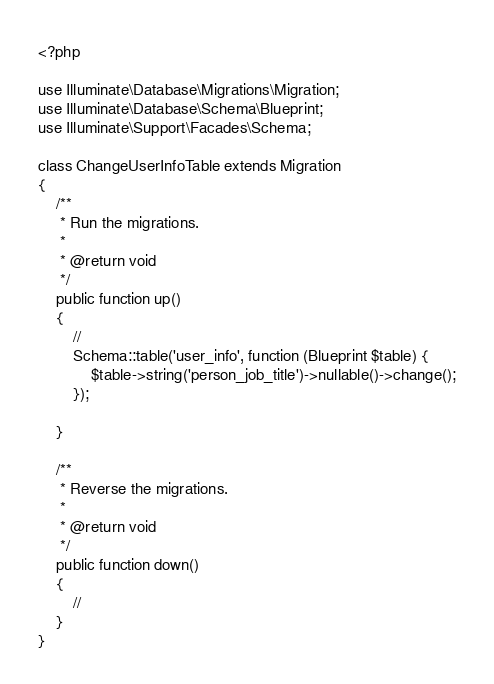Convert code to text. <code><loc_0><loc_0><loc_500><loc_500><_PHP_><?php

use Illuminate\Database\Migrations\Migration;
use Illuminate\Database\Schema\Blueprint;
use Illuminate\Support\Facades\Schema;

class ChangeUserInfoTable extends Migration
{
    /**
     * Run the migrations.
     *
     * @return void
     */
    public function up()
    {
        //
		Schema::table('user_info', function (Blueprint $table) {
			$table->string('person_job_title')->nullable()->change();
		});

    }

    /**
     * Reverse the migrations.
     *
     * @return void
     */
    public function down()
    {
        //
    }
}
</code> 